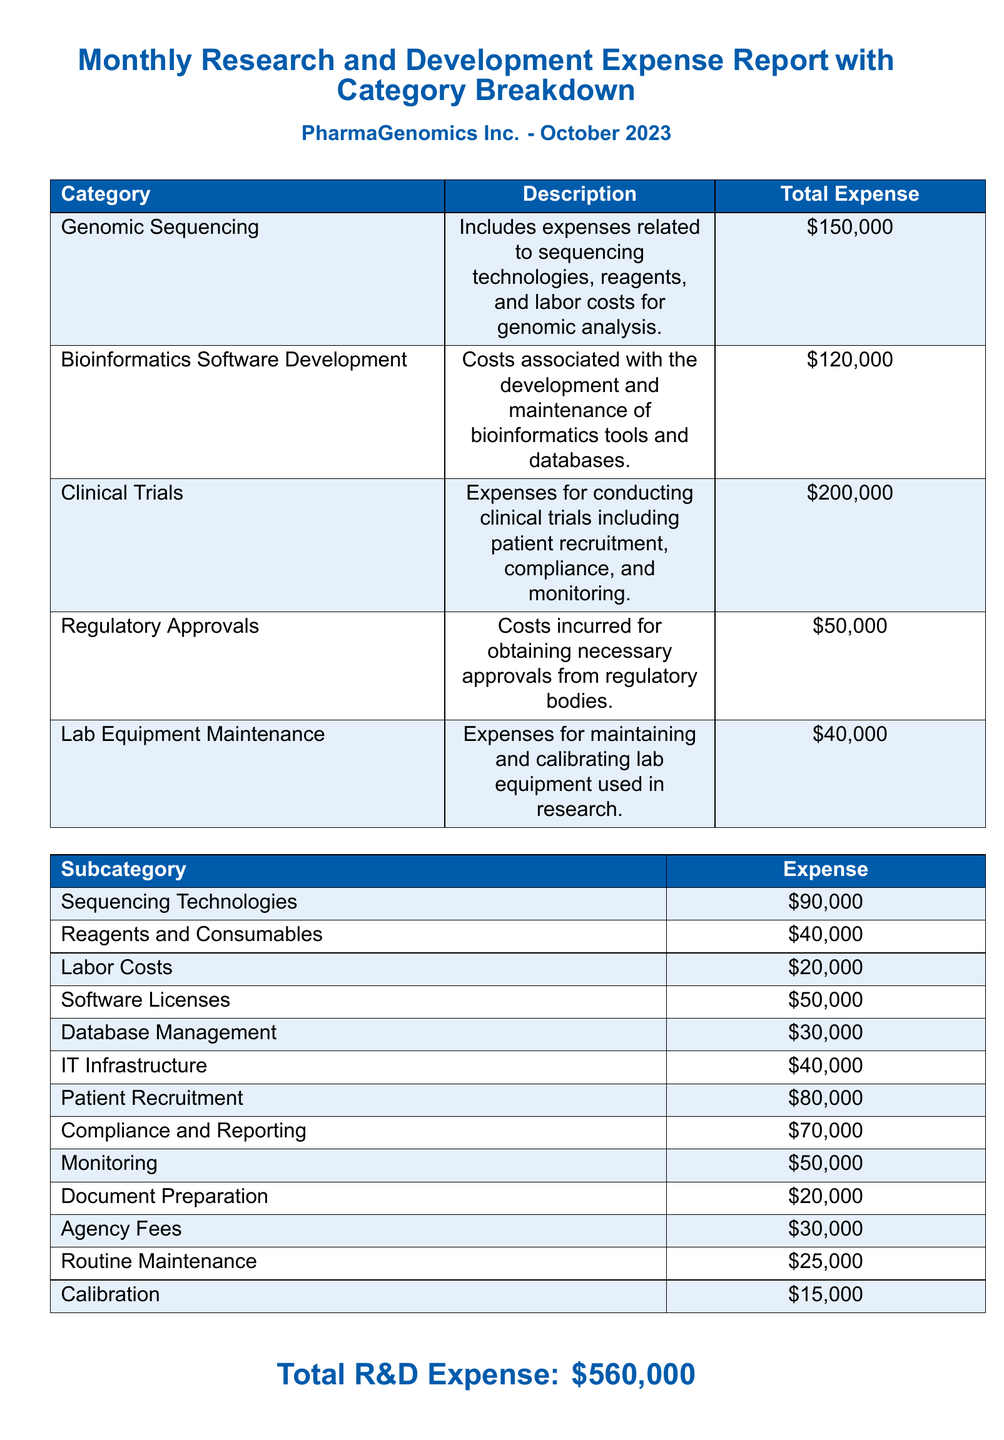What is the total R&D expense? The total R&D expense is provided at the bottom of the document as the overall figure for October 2023.
Answer: $560,000 What is the expense for Clinical Trials? The expense for Clinical Trials is listed under the Category Breakdown section as specified in the document.
Answer: $200,000 Which category has the lowest total expense? The categories and their corresponding total expenses are summarized in the document, helping to identify the one with the least amount.
Answer: Regulatory Approvals How much is spent on Sequencing Technologies? The subcategory expenses are detailed in a separate table, providing specific figures for each subcategory within the main categories.
Answer: $90,000 What percentage of the total R&D expense is allocated to Bioinformatics Software Development? This requires calculating the fraction of the Bioinformatics Software Development expense over the total R&D expense.
Answer: 21.43% What does the Lab Equipment Maintenance cover? The document includes a description of what the Lab Equipment Maintenance category encompasses in the table.
Answer: Maintenance and calibration What is included in the expense for Patient Recruitment? The nature of the expenses in the Clinical Trials category provides insights into what the Patient Recruitment entails.
Answer: Patient recruitment How many subcategories are listed under the main categories? The document explicitly lists all subcategories under the main categories, which can be counted for this answer.
Answer: 13 